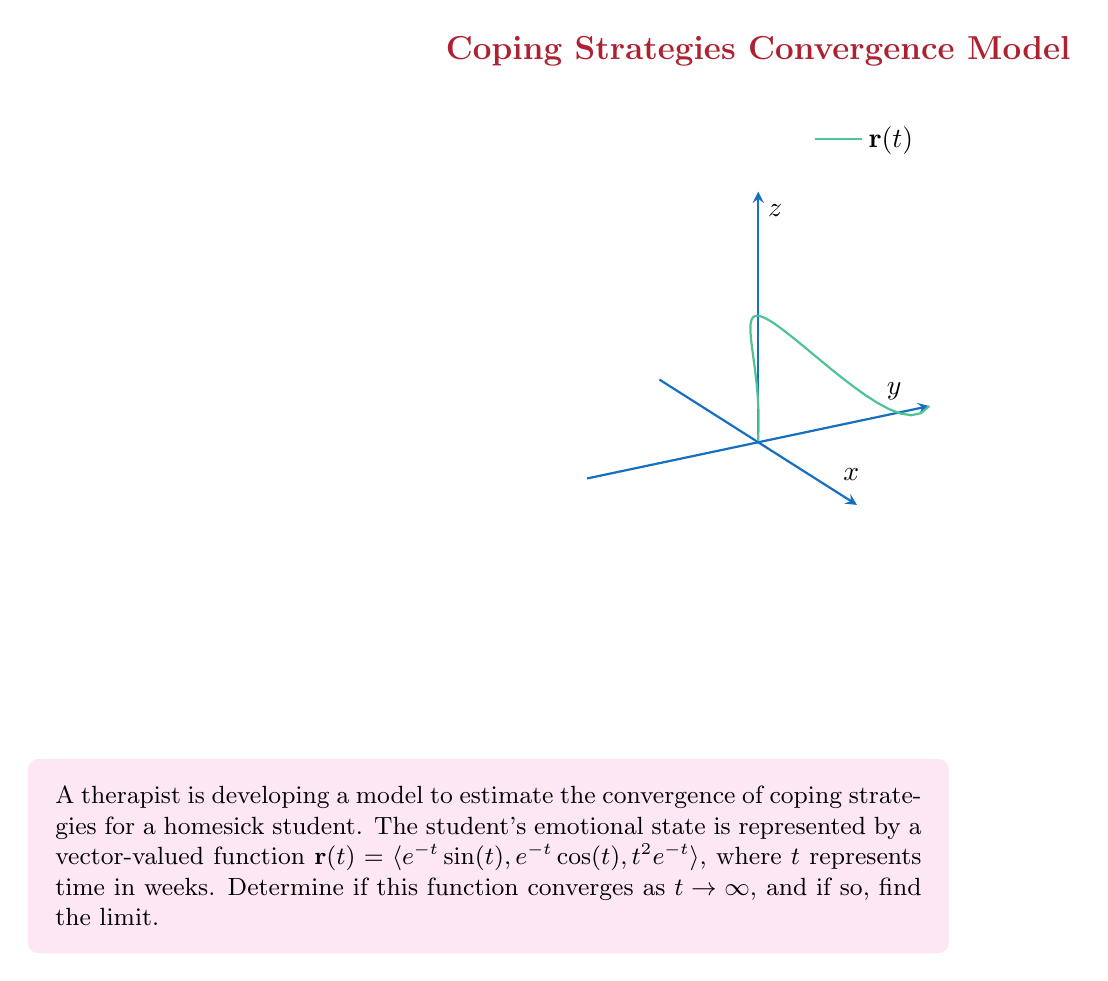Show me your answer to this math problem. To determine if the vector-valued function converges as $t \to \infty$, we need to examine the limit of each component:

1) For the first component: $\lim_{t \to \infty} e^{-t}\sin(t)$
   $|e^{-t}\sin(t)| \leq e^{-t}$ (since $|\sin(t)| \leq 1$)
   As $t \to \infty$, $e^{-t} \to 0$, so this component converges to 0.

2) For the second component: $\lim_{t \to \infty} e^{-t}\cos(t)$
   Similar to the first component, $|e^{-t}\cos(t)| \leq e^{-t} \to 0$ as $t \to \infty$.

3) For the third component: $\lim_{t \to \infty} t^2e^{-t}$
   We can use L'Hôpital's rule twice:
   $\lim_{t \to \infty} \frac{t^2}{e^t} = \lim_{t \to \infty} \frac{2t}{e^t} = \lim_{t \to \infty} \frac{2}{e^t} = 0$

Since all three components converge to 0 as $t \to \infty$, the vector-valued function converges to the zero vector:

$$\lim_{t \to \infty} \mathbf{r}(t) = \lim_{t \to \infty} \langle e^{-t}\sin(t), e^{-t}\cos(t), t^2e^{-t} \rangle = \langle 0, 0, 0 \rangle$$

This convergence suggests that the student's emotional state stabilizes over time as they adjust to their new environment and overcome homesickness.
Answer: $\langle 0, 0, 0 \rangle$ 